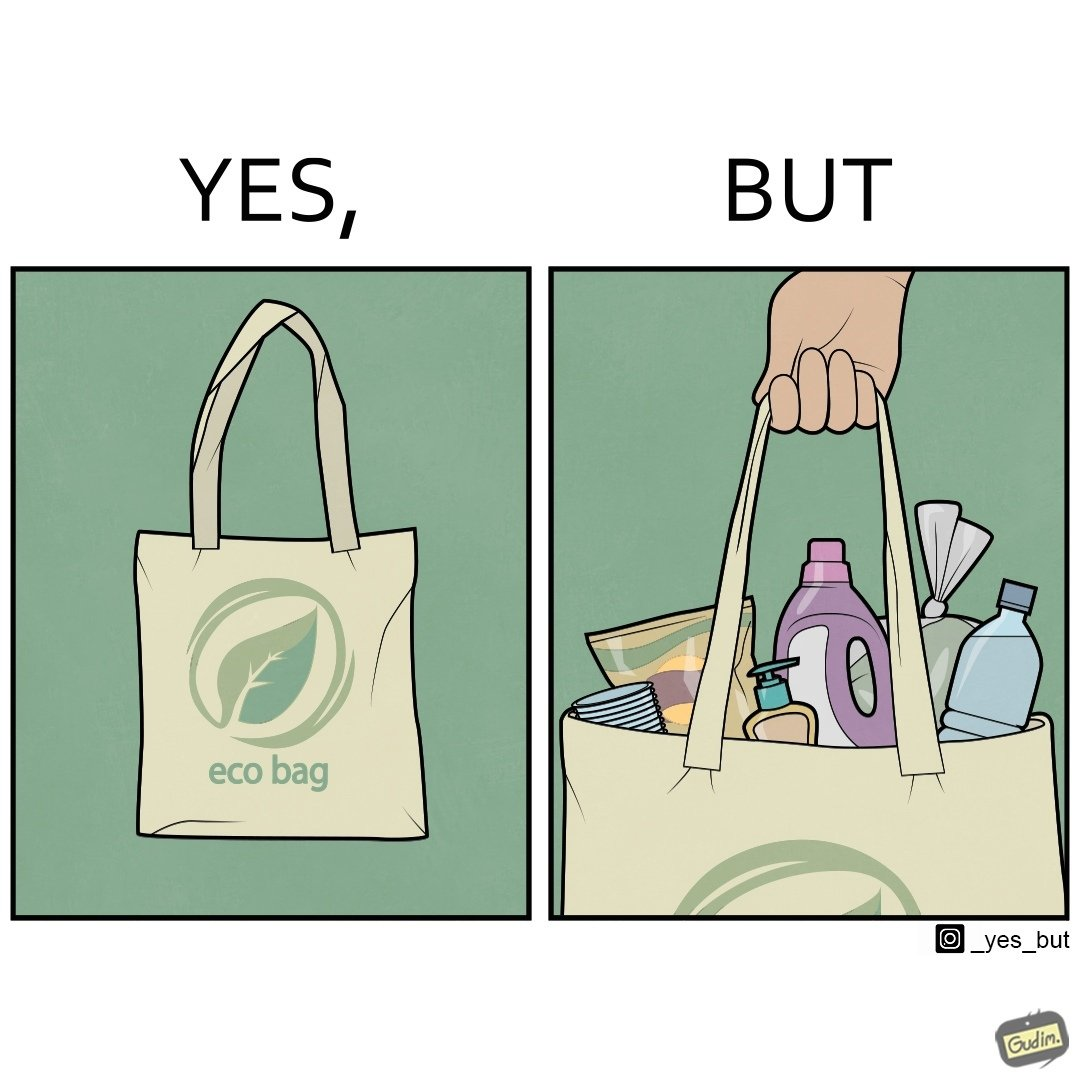Compare the left and right sides of this image. In the left part of the image: a bag with text "eco-bag" on it, probably made up of some eco-friendly materials like cotton or jute In the right part of the image: a person carrying different products inside plastic containers or plastic wrapping in a carry bag 